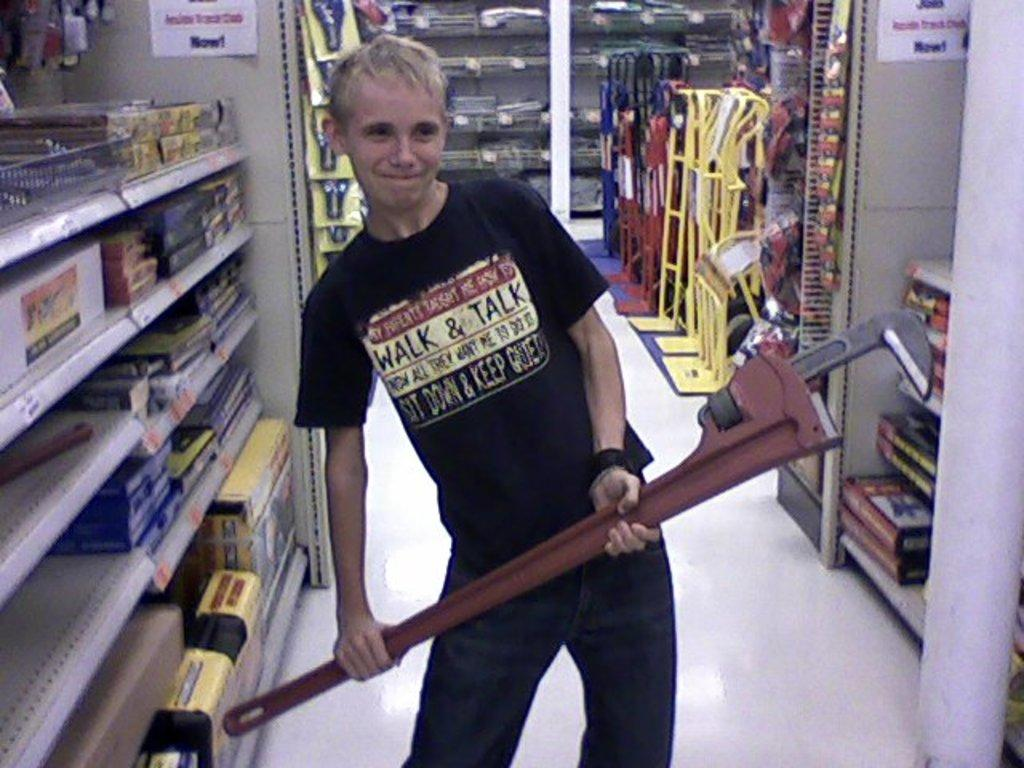<image>
Summarize the visual content of the image. a man wearing a shirt that says 'walk & talk' on it 